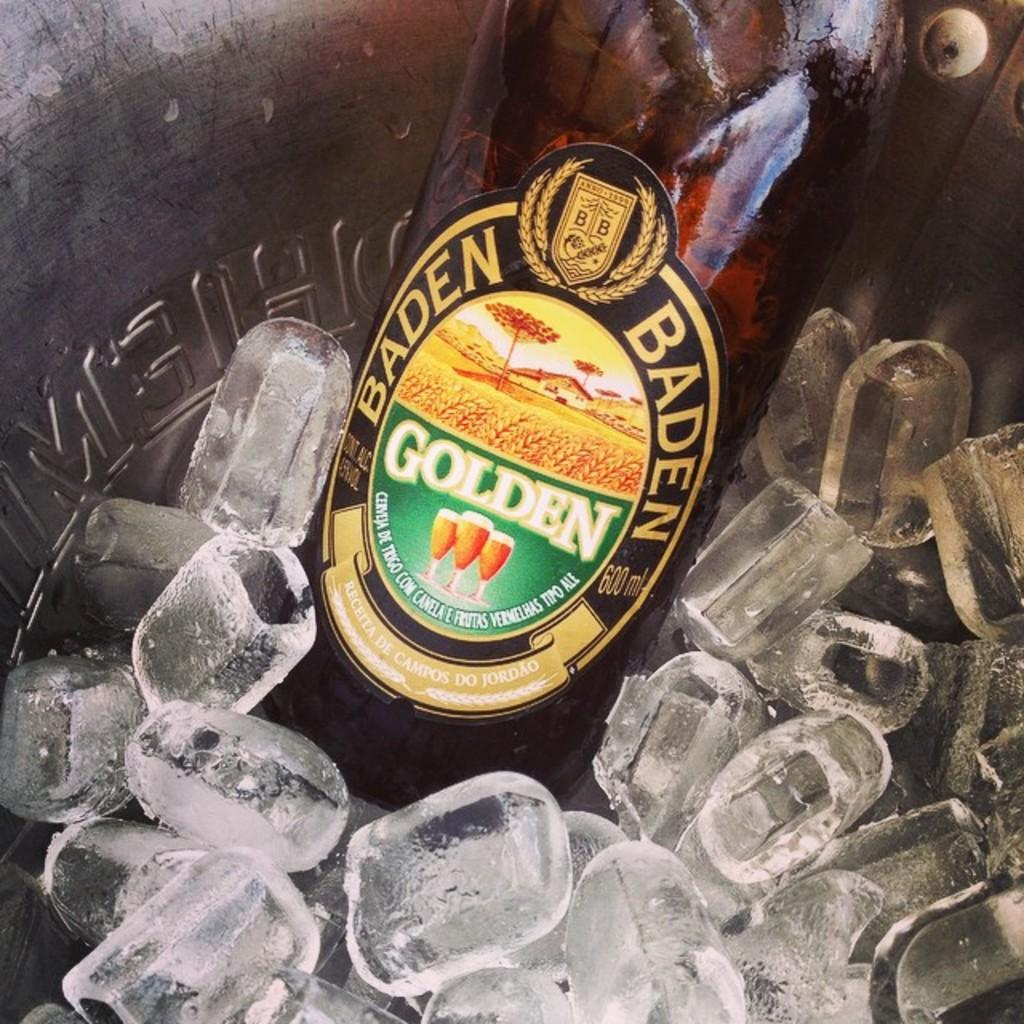<image>
Offer a succinct explanation of the picture presented. A container holds ice and a bottle of Baden Golden 